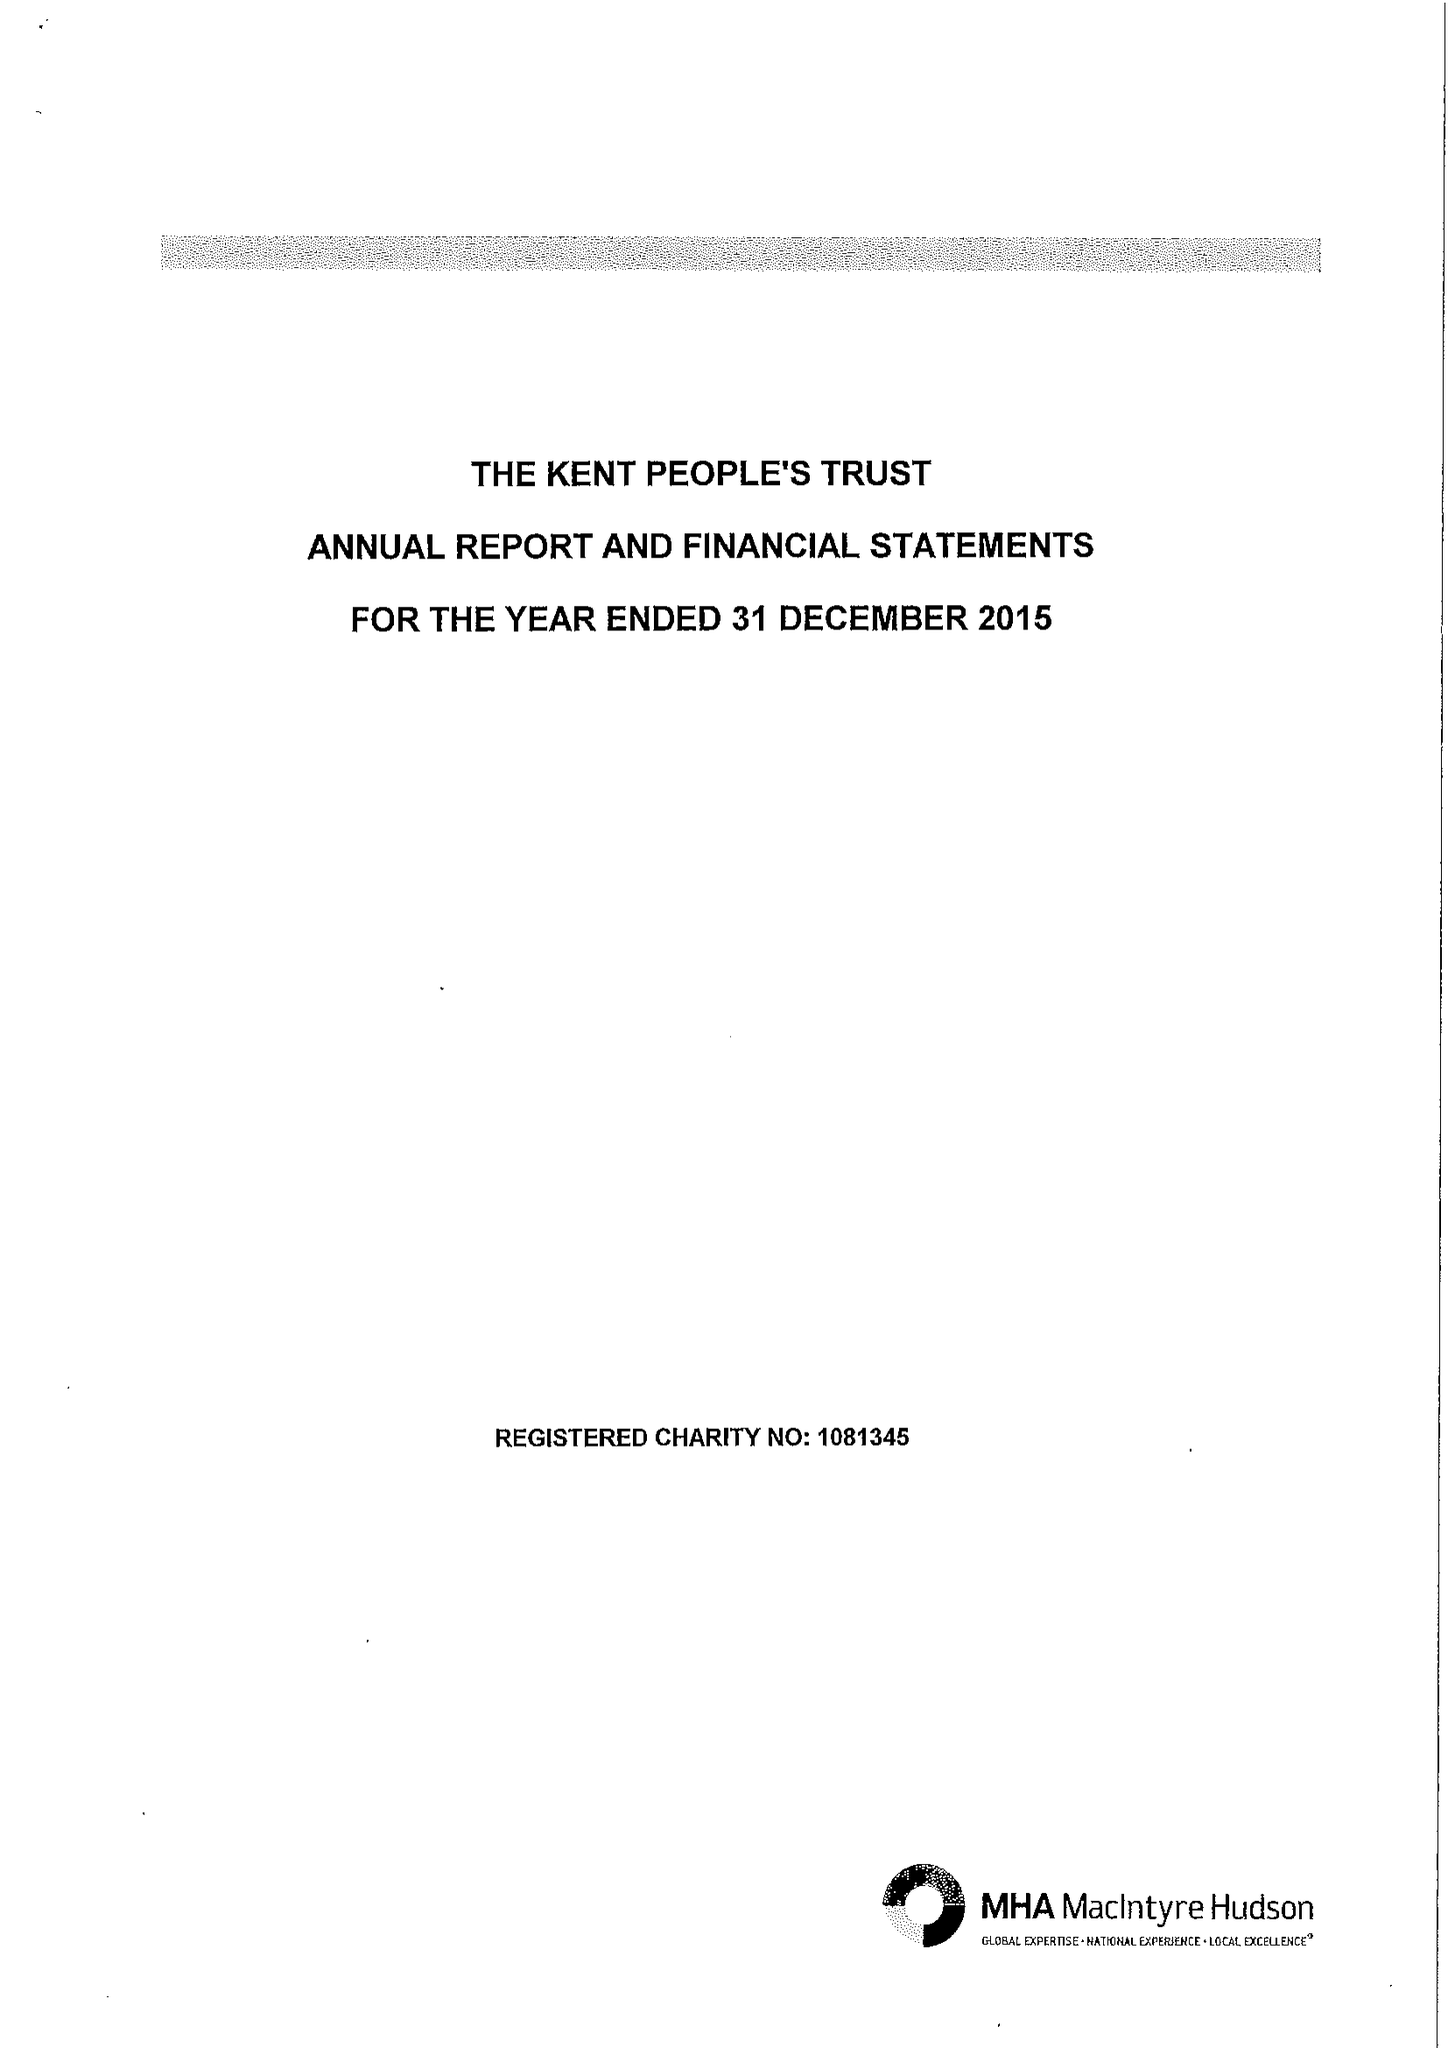What is the value for the spending_annually_in_british_pounds?
Answer the question using a single word or phrase. 90607.00 